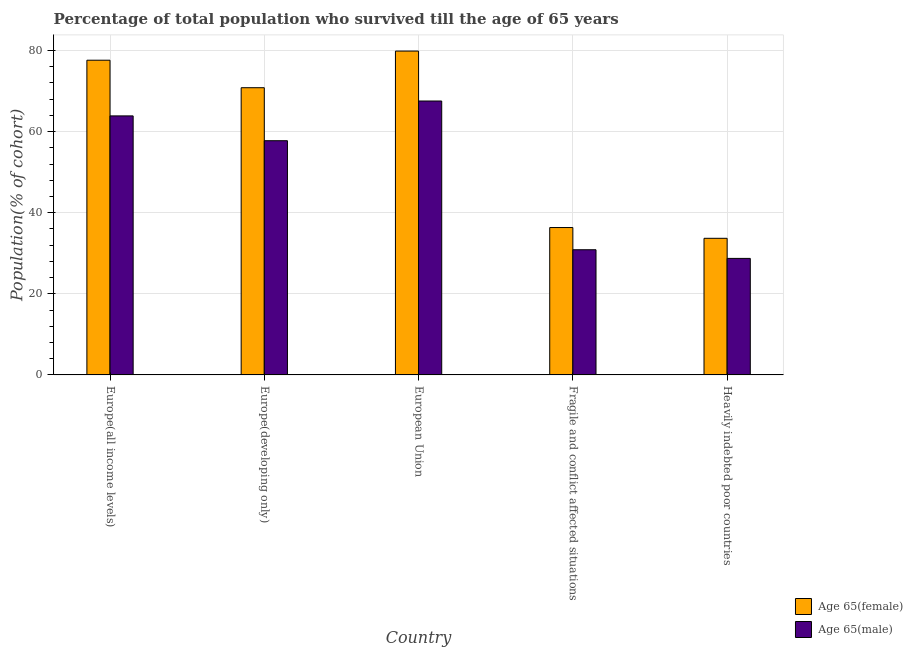How many bars are there on the 4th tick from the right?
Your answer should be compact. 2. What is the percentage of male population who survived till age of 65 in Europe(all income levels)?
Your answer should be compact. 63.87. Across all countries, what is the maximum percentage of male population who survived till age of 65?
Your answer should be compact. 67.54. Across all countries, what is the minimum percentage of male population who survived till age of 65?
Make the answer very short. 28.73. In which country was the percentage of male population who survived till age of 65 minimum?
Keep it short and to the point. Heavily indebted poor countries. What is the total percentage of male population who survived till age of 65 in the graph?
Offer a terse response. 248.75. What is the difference between the percentage of male population who survived till age of 65 in European Union and that in Heavily indebted poor countries?
Keep it short and to the point. 38.81. What is the difference between the percentage of male population who survived till age of 65 in European Union and the percentage of female population who survived till age of 65 in Europe(developing only)?
Keep it short and to the point. -3.28. What is the average percentage of female population who survived till age of 65 per country?
Provide a succinct answer. 59.66. What is the difference between the percentage of male population who survived till age of 65 and percentage of female population who survived till age of 65 in Europe(developing only)?
Offer a terse response. -13.07. In how many countries, is the percentage of female population who survived till age of 65 greater than 48 %?
Provide a succinct answer. 3. What is the ratio of the percentage of female population who survived till age of 65 in Europe(all income levels) to that in Heavily indebted poor countries?
Your response must be concise. 2.3. Is the difference between the percentage of male population who survived till age of 65 in European Union and Heavily indebted poor countries greater than the difference between the percentage of female population who survived till age of 65 in European Union and Heavily indebted poor countries?
Provide a succinct answer. No. What is the difference between the highest and the second highest percentage of female population who survived till age of 65?
Ensure brevity in your answer.  2.25. What is the difference between the highest and the lowest percentage of female population who survived till age of 65?
Offer a very short reply. 46.17. In how many countries, is the percentage of male population who survived till age of 65 greater than the average percentage of male population who survived till age of 65 taken over all countries?
Offer a very short reply. 3. Is the sum of the percentage of female population who survived till age of 65 in Europe(all income levels) and European Union greater than the maximum percentage of male population who survived till age of 65 across all countries?
Offer a very short reply. Yes. What does the 2nd bar from the left in Fragile and conflict affected situations represents?
Your response must be concise. Age 65(male). What does the 2nd bar from the right in Fragile and conflict affected situations represents?
Provide a short and direct response. Age 65(female). How many bars are there?
Ensure brevity in your answer.  10. Are all the bars in the graph horizontal?
Offer a terse response. No. What is the difference between two consecutive major ticks on the Y-axis?
Make the answer very short. 20. Are the values on the major ticks of Y-axis written in scientific E-notation?
Ensure brevity in your answer.  No. Does the graph contain any zero values?
Your answer should be very brief. No. Where does the legend appear in the graph?
Offer a very short reply. Bottom right. What is the title of the graph?
Give a very brief answer. Percentage of total population who survived till the age of 65 years. What is the label or title of the Y-axis?
Offer a terse response. Population(% of cohort). What is the Population(% of cohort) of Age 65(female) in Europe(all income levels)?
Your answer should be compact. 77.6. What is the Population(% of cohort) of Age 65(male) in Europe(all income levels)?
Offer a very short reply. 63.87. What is the Population(% of cohort) of Age 65(female) in Europe(developing only)?
Your answer should be very brief. 70.82. What is the Population(% of cohort) in Age 65(male) in Europe(developing only)?
Make the answer very short. 57.75. What is the Population(% of cohort) in Age 65(female) in European Union?
Give a very brief answer. 79.85. What is the Population(% of cohort) of Age 65(male) in European Union?
Ensure brevity in your answer.  67.54. What is the Population(% of cohort) in Age 65(female) in Fragile and conflict affected situations?
Your answer should be very brief. 36.34. What is the Population(% of cohort) in Age 65(male) in Fragile and conflict affected situations?
Keep it short and to the point. 30.86. What is the Population(% of cohort) in Age 65(female) in Heavily indebted poor countries?
Provide a short and direct response. 33.69. What is the Population(% of cohort) of Age 65(male) in Heavily indebted poor countries?
Your answer should be compact. 28.73. Across all countries, what is the maximum Population(% of cohort) of Age 65(female)?
Ensure brevity in your answer.  79.85. Across all countries, what is the maximum Population(% of cohort) in Age 65(male)?
Offer a terse response. 67.54. Across all countries, what is the minimum Population(% of cohort) in Age 65(female)?
Keep it short and to the point. 33.69. Across all countries, what is the minimum Population(% of cohort) of Age 65(male)?
Give a very brief answer. 28.73. What is the total Population(% of cohort) in Age 65(female) in the graph?
Your answer should be compact. 298.29. What is the total Population(% of cohort) in Age 65(male) in the graph?
Provide a succinct answer. 248.75. What is the difference between the Population(% of cohort) of Age 65(female) in Europe(all income levels) and that in Europe(developing only)?
Make the answer very short. 6.78. What is the difference between the Population(% of cohort) in Age 65(male) in Europe(all income levels) and that in Europe(developing only)?
Ensure brevity in your answer.  6.12. What is the difference between the Population(% of cohort) of Age 65(female) in Europe(all income levels) and that in European Union?
Make the answer very short. -2.25. What is the difference between the Population(% of cohort) of Age 65(male) in Europe(all income levels) and that in European Union?
Make the answer very short. -3.67. What is the difference between the Population(% of cohort) of Age 65(female) in Europe(all income levels) and that in Fragile and conflict affected situations?
Keep it short and to the point. 41.26. What is the difference between the Population(% of cohort) of Age 65(male) in Europe(all income levels) and that in Fragile and conflict affected situations?
Make the answer very short. 33. What is the difference between the Population(% of cohort) in Age 65(female) in Europe(all income levels) and that in Heavily indebted poor countries?
Give a very brief answer. 43.91. What is the difference between the Population(% of cohort) in Age 65(male) in Europe(all income levels) and that in Heavily indebted poor countries?
Make the answer very short. 35.14. What is the difference between the Population(% of cohort) of Age 65(female) in Europe(developing only) and that in European Union?
Offer a terse response. -9.04. What is the difference between the Population(% of cohort) of Age 65(male) in Europe(developing only) and that in European Union?
Keep it short and to the point. -9.79. What is the difference between the Population(% of cohort) in Age 65(female) in Europe(developing only) and that in Fragile and conflict affected situations?
Offer a terse response. 34.48. What is the difference between the Population(% of cohort) of Age 65(male) in Europe(developing only) and that in Fragile and conflict affected situations?
Make the answer very short. 26.88. What is the difference between the Population(% of cohort) of Age 65(female) in Europe(developing only) and that in Heavily indebted poor countries?
Make the answer very short. 37.13. What is the difference between the Population(% of cohort) in Age 65(male) in Europe(developing only) and that in Heavily indebted poor countries?
Give a very brief answer. 29.02. What is the difference between the Population(% of cohort) of Age 65(female) in European Union and that in Fragile and conflict affected situations?
Provide a short and direct response. 43.51. What is the difference between the Population(% of cohort) of Age 65(male) in European Union and that in Fragile and conflict affected situations?
Keep it short and to the point. 36.67. What is the difference between the Population(% of cohort) of Age 65(female) in European Union and that in Heavily indebted poor countries?
Your response must be concise. 46.17. What is the difference between the Population(% of cohort) of Age 65(male) in European Union and that in Heavily indebted poor countries?
Your answer should be compact. 38.81. What is the difference between the Population(% of cohort) in Age 65(female) in Fragile and conflict affected situations and that in Heavily indebted poor countries?
Make the answer very short. 2.65. What is the difference between the Population(% of cohort) in Age 65(male) in Fragile and conflict affected situations and that in Heavily indebted poor countries?
Ensure brevity in your answer.  2.14. What is the difference between the Population(% of cohort) in Age 65(female) in Europe(all income levels) and the Population(% of cohort) in Age 65(male) in Europe(developing only)?
Offer a terse response. 19.85. What is the difference between the Population(% of cohort) of Age 65(female) in Europe(all income levels) and the Population(% of cohort) of Age 65(male) in European Union?
Give a very brief answer. 10.06. What is the difference between the Population(% of cohort) in Age 65(female) in Europe(all income levels) and the Population(% of cohort) in Age 65(male) in Fragile and conflict affected situations?
Give a very brief answer. 46.73. What is the difference between the Population(% of cohort) of Age 65(female) in Europe(all income levels) and the Population(% of cohort) of Age 65(male) in Heavily indebted poor countries?
Keep it short and to the point. 48.87. What is the difference between the Population(% of cohort) in Age 65(female) in Europe(developing only) and the Population(% of cohort) in Age 65(male) in European Union?
Your answer should be very brief. 3.28. What is the difference between the Population(% of cohort) in Age 65(female) in Europe(developing only) and the Population(% of cohort) in Age 65(male) in Fragile and conflict affected situations?
Your response must be concise. 39.95. What is the difference between the Population(% of cohort) in Age 65(female) in Europe(developing only) and the Population(% of cohort) in Age 65(male) in Heavily indebted poor countries?
Make the answer very short. 42.09. What is the difference between the Population(% of cohort) of Age 65(female) in European Union and the Population(% of cohort) of Age 65(male) in Fragile and conflict affected situations?
Your response must be concise. 48.99. What is the difference between the Population(% of cohort) of Age 65(female) in European Union and the Population(% of cohort) of Age 65(male) in Heavily indebted poor countries?
Your response must be concise. 51.12. What is the difference between the Population(% of cohort) of Age 65(female) in Fragile and conflict affected situations and the Population(% of cohort) of Age 65(male) in Heavily indebted poor countries?
Provide a short and direct response. 7.61. What is the average Population(% of cohort) in Age 65(female) per country?
Your response must be concise. 59.66. What is the average Population(% of cohort) in Age 65(male) per country?
Provide a succinct answer. 49.75. What is the difference between the Population(% of cohort) of Age 65(female) and Population(% of cohort) of Age 65(male) in Europe(all income levels)?
Ensure brevity in your answer.  13.73. What is the difference between the Population(% of cohort) of Age 65(female) and Population(% of cohort) of Age 65(male) in Europe(developing only)?
Keep it short and to the point. 13.07. What is the difference between the Population(% of cohort) in Age 65(female) and Population(% of cohort) in Age 65(male) in European Union?
Keep it short and to the point. 12.31. What is the difference between the Population(% of cohort) in Age 65(female) and Population(% of cohort) in Age 65(male) in Fragile and conflict affected situations?
Your answer should be compact. 5.47. What is the difference between the Population(% of cohort) of Age 65(female) and Population(% of cohort) of Age 65(male) in Heavily indebted poor countries?
Ensure brevity in your answer.  4.96. What is the ratio of the Population(% of cohort) in Age 65(female) in Europe(all income levels) to that in Europe(developing only)?
Provide a short and direct response. 1.1. What is the ratio of the Population(% of cohort) of Age 65(male) in Europe(all income levels) to that in Europe(developing only)?
Give a very brief answer. 1.11. What is the ratio of the Population(% of cohort) of Age 65(female) in Europe(all income levels) to that in European Union?
Your answer should be compact. 0.97. What is the ratio of the Population(% of cohort) in Age 65(male) in Europe(all income levels) to that in European Union?
Offer a very short reply. 0.95. What is the ratio of the Population(% of cohort) of Age 65(female) in Europe(all income levels) to that in Fragile and conflict affected situations?
Provide a short and direct response. 2.14. What is the ratio of the Population(% of cohort) in Age 65(male) in Europe(all income levels) to that in Fragile and conflict affected situations?
Keep it short and to the point. 2.07. What is the ratio of the Population(% of cohort) in Age 65(female) in Europe(all income levels) to that in Heavily indebted poor countries?
Your answer should be very brief. 2.3. What is the ratio of the Population(% of cohort) of Age 65(male) in Europe(all income levels) to that in Heavily indebted poor countries?
Make the answer very short. 2.22. What is the ratio of the Population(% of cohort) in Age 65(female) in Europe(developing only) to that in European Union?
Ensure brevity in your answer.  0.89. What is the ratio of the Population(% of cohort) in Age 65(male) in Europe(developing only) to that in European Union?
Offer a very short reply. 0.85. What is the ratio of the Population(% of cohort) in Age 65(female) in Europe(developing only) to that in Fragile and conflict affected situations?
Offer a very short reply. 1.95. What is the ratio of the Population(% of cohort) of Age 65(male) in Europe(developing only) to that in Fragile and conflict affected situations?
Give a very brief answer. 1.87. What is the ratio of the Population(% of cohort) in Age 65(female) in Europe(developing only) to that in Heavily indebted poor countries?
Offer a very short reply. 2.1. What is the ratio of the Population(% of cohort) in Age 65(male) in Europe(developing only) to that in Heavily indebted poor countries?
Make the answer very short. 2.01. What is the ratio of the Population(% of cohort) in Age 65(female) in European Union to that in Fragile and conflict affected situations?
Offer a terse response. 2.2. What is the ratio of the Population(% of cohort) in Age 65(male) in European Union to that in Fragile and conflict affected situations?
Provide a succinct answer. 2.19. What is the ratio of the Population(% of cohort) in Age 65(female) in European Union to that in Heavily indebted poor countries?
Make the answer very short. 2.37. What is the ratio of the Population(% of cohort) of Age 65(male) in European Union to that in Heavily indebted poor countries?
Keep it short and to the point. 2.35. What is the ratio of the Population(% of cohort) of Age 65(female) in Fragile and conflict affected situations to that in Heavily indebted poor countries?
Your answer should be compact. 1.08. What is the ratio of the Population(% of cohort) of Age 65(male) in Fragile and conflict affected situations to that in Heavily indebted poor countries?
Give a very brief answer. 1.07. What is the difference between the highest and the second highest Population(% of cohort) in Age 65(female)?
Your answer should be compact. 2.25. What is the difference between the highest and the second highest Population(% of cohort) in Age 65(male)?
Your answer should be very brief. 3.67. What is the difference between the highest and the lowest Population(% of cohort) of Age 65(female)?
Provide a succinct answer. 46.17. What is the difference between the highest and the lowest Population(% of cohort) in Age 65(male)?
Your answer should be compact. 38.81. 